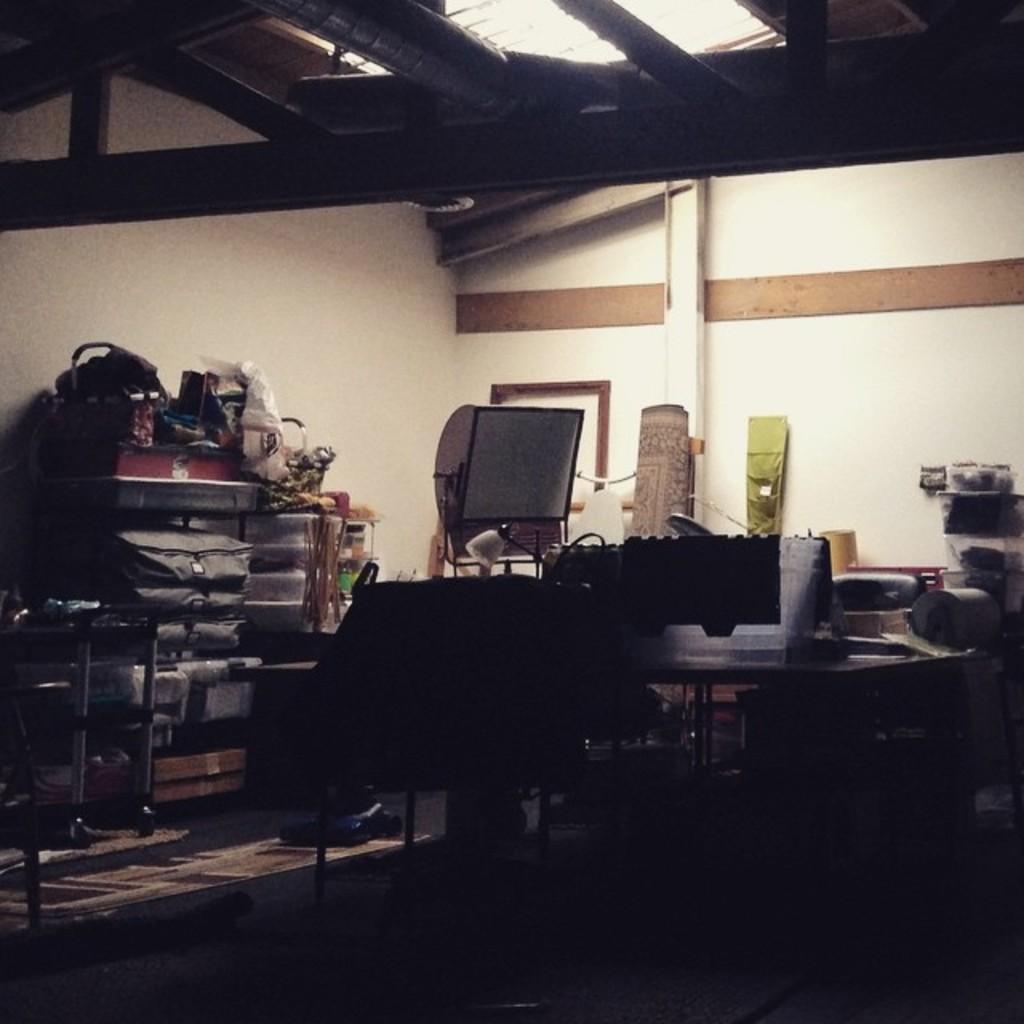In one or two sentences, can you explain what this image depicts? In this image we can see inside of a house. There are many objects in the image. There are many objects placed on the rack. There are few lights at the top of the image. 